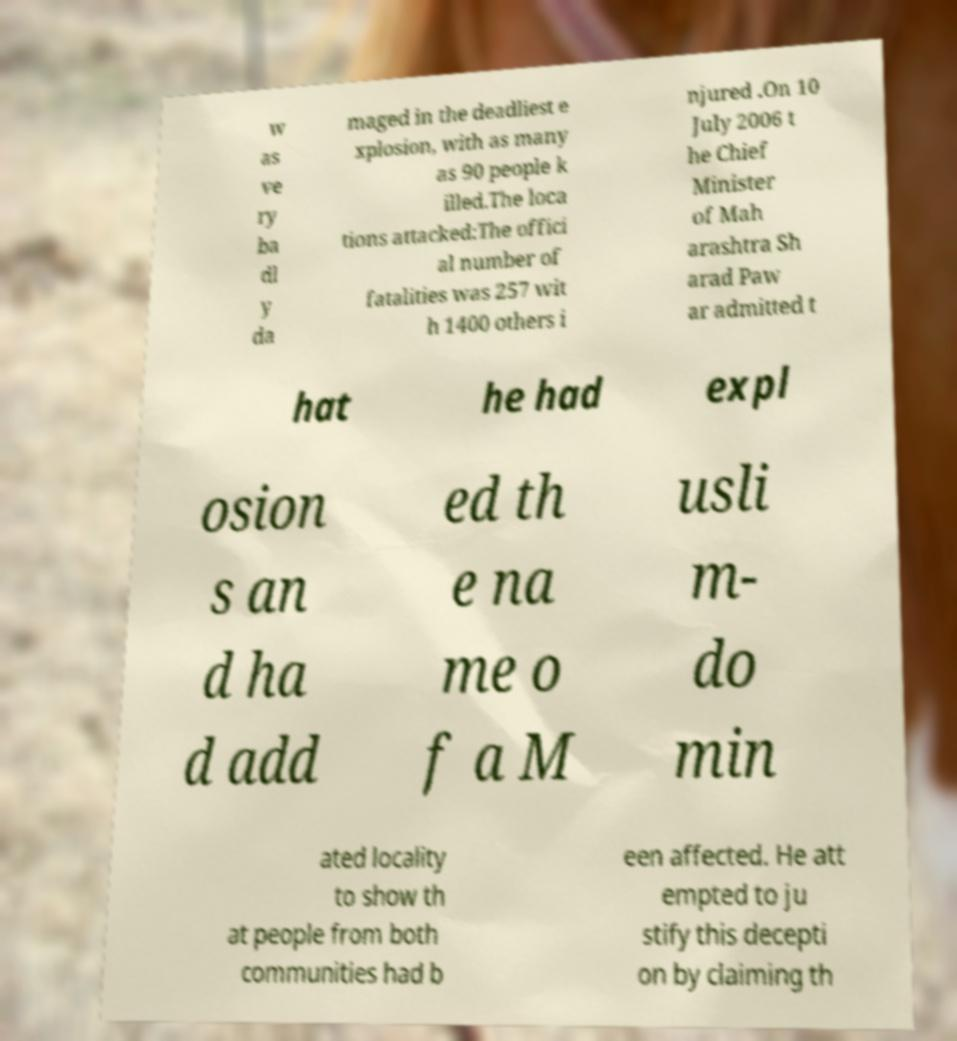For documentation purposes, I need the text within this image transcribed. Could you provide that? w as ve ry ba dl y da maged in the deadliest e xplosion, with as many as 90 people k illed.The loca tions attacked:The offici al number of fatalities was 257 wit h 1400 others i njured .On 10 July 2006 t he Chief Minister of Mah arashtra Sh arad Paw ar admitted t hat he had expl osion s an d ha d add ed th e na me o f a M usli m- do min ated locality to show th at people from both communities had b een affected. He att empted to ju stify this decepti on by claiming th 